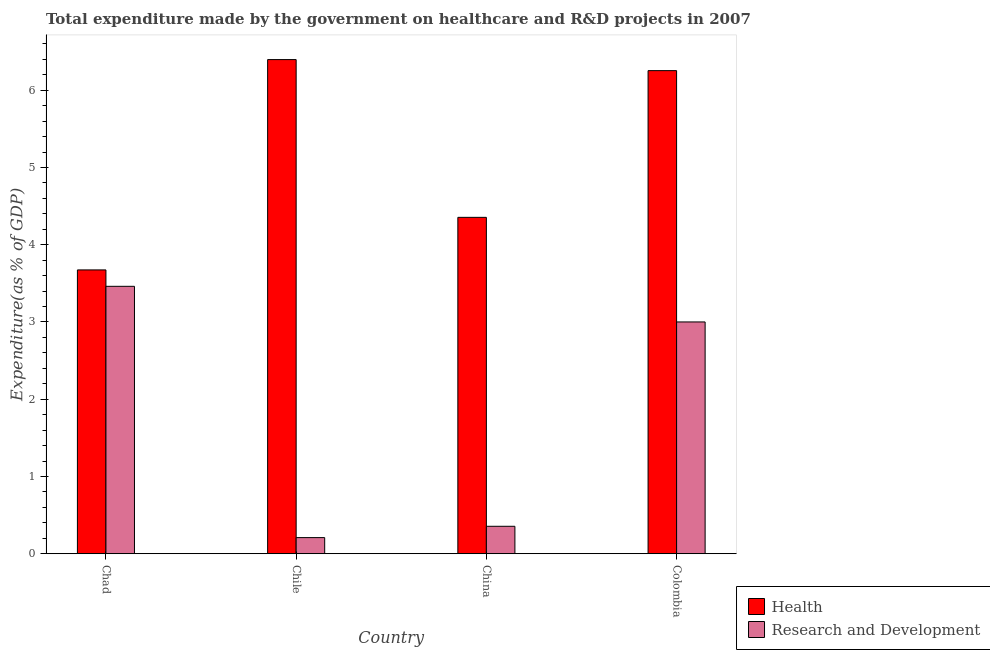How many groups of bars are there?
Ensure brevity in your answer.  4. Are the number of bars on each tick of the X-axis equal?
Make the answer very short. Yes. How many bars are there on the 1st tick from the left?
Provide a short and direct response. 2. How many bars are there on the 1st tick from the right?
Provide a short and direct response. 2. What is the label of the 1st group of bars from the left?
Your answer should be very brief. Chad. In how many cases, is the number of bars for a given country not equal to the number of legend labels?
Your answer should be compact. 0. What is the expenditure in healthcare in Chile?
Provide a short and direct response. 6.4. Across all countries, what is the maximum expenditure in healthcare?
Provide a succinct answer. 6.4. Across all countries, what is the minimum expenditure in healthcare?
Provide a succinct answer. 3.67. What is the total expenditure in r&d in the graph?
Provide a succinct answer. 7.03. What is the difference between the expenditure in r&d in Chad and that in Colombia?
Keep it short and to the point. 0.46. What is the difference between the expenditure in r&d in China and the expenditure in healthcare in Colombia?
Give a very brief answer. -5.9. What is the average expenditure in healthcare per country?
Offer a very short reply. 5.17. What is the difference between the expenditure in r&d and expenditure in healthcare in Chile?
Offer a terse response. -6.19. What is the ratio of the expenditure in healthcare in China to that in Colombia?
Your response must be concise. 0.7. What is the difference between the highest and the second highest expenditure in healthcare?
Make the answer very short. 0.14. What is the difference between the highest and the lowest expenditure in r&d?
Offer a terse response. 3.25. Is the sum of the expenditure in r&d in Chad and Chile greater than the maximum expenditure in healthcare across all countries?
Provide a succinct answer. No. What does the 1st bar from the left in Chile represents?
Make the answer very short. Health. What does the 2nd bar from the right in Chad represents?
Offer a terse response. Health. How many bars are there?
Make the answer very short. 8. How many countries are there in the graph?
Provide a short and direct response. 4. Does the graph contain any zero values?
Ensure brevity in your answer.  No. Does the graph contain grids?
Offer a terse response. No. What is the title of the graph?
Your answer should be compact. Total expenditure made by the government on healthcare and R&D projects in 2007. What is the label or title of the Y-axis?
Offer a terse response. Expenditure(as % of GDP). What is the Expenditure(as % of GDP) of Health in Chad?
Your answer should be compact. 3.67. What is the Expenditure(as % of GDP) of Research and Development in Chad?
Keep it short and to the point. 3.46. What is the Expenditure(as % of GDP) of Health in Chile?
Your answer should be very brief. 6.4. What is the Expenditure(as % of GDP) of Research and Development in Chile?
Keep it short and to the point. 0.21. What is the Expenditure(as % of GDP) of Health in China?
Your response must be concise. 4.35. What is the Expenditure(as % of GDP) in Research and Development in China?
Make the answer very short. 0.36. What is the Expenditure(as % of GDP) in Health in Colombia?
Give a very brief answer. 6.25. What is the Expenditure(as % of GDP) of Research and Development in Colombia?
Offer a terse response. 3. Across all countries, what is the maximum Expenditure(as % of GDP) in Health?
Provide a succinct answer. 6.4. Across all countries, what is the maximum Expenditure(as % of GDP) in Research and Development?
Provide a succinct answer. 3.46. Across all countries, what is the minimum Expenditure(as % of GDP) in Health?
Provide a short and direct response. 3.67. Across all countries, what is the minimum Expenditure(as % of GDP) in Research and Development?
Your answer should be compact. 0.21. What is the total Expenditure(as % of GDP) in Health in the graph?
Make the answer very short. 20.68. What is the total Expenditure(as % of GDP) of Research and Development in the graph?
Provide a succinct answer. 7.03. What is the difference between the Expenditure(as % of GDP) in Health in Chad and that in Chile?
Offer a very short reply. -2.72. What is the difference between the Expenditure(as % of GDP) of Research and Development in Chad and that in Chile?
Offer a very short reply. 3.25. What is the difference between the Expenditure(as % of GDP) of Health in Chad and that in China?
Make the answer very short. -0.68. What is the difference between the Expenditure(as % of GDP) in Research and Development in Chad and that in China?
Your answer should be very brief. 3.11. What is the difference between the Expenditure(as % of GDP) of Health in Chad and that in Colombia?
Your response must be concise. -2.58. What is the difference between the Expenditure(as % of GDP) in Research and Development in Chad and that in Colombia?
Keep it short and to the point. 0.46. What is the difference between the Expenditure(as % of GDP) of Health in Chile and that in China?
Ensure brevity in your answer.  2.04. What is the difference between the Expenditure(as % of GDP) in Research and Development in Chile and that in China?
Give a very brief answer. -0.15. What is the difference between the Expenditure(as % of GDP) in Health in Chile and that in Colombia?
Provide a succinct answer. 0.14. What is the difference between the Expenditure(as % of GDP) in Research and Development in Chile and that in Colombia?
Your response must be concise. -2.79. What is the difference between the Expenditure(as % of GDP) in Health in China and that in Colombia?
Your answer should be very brief. -1.9. What is the difference between the Expenditure(as % of GDP) in Research and Development in China and that in Colombia?
Offer a very short reply. -2.65. What is the difference between the Expenditure(as % of GDP) in Health in Chad and the Expenditure(as % of GDP) in Research and Development in Chile?
Ensure brevity in your answer.  3.47. What is the difference between the Expenditure(as % of GDP) of Health in Chad and the Expenditure(as % of GDP) of Research and Development in China?
Provide a succinct answer. 3.32. What is the difference between the Expenditure(as % of GDP) of Health in Chad and the Expenditure(as % of GDP) of Research and Development in Colombia?
Make the answer very short. 0.67. What is the difference between the Expenditure(as % of GDP) of Health in Chile and the Expenditure(as % of GDP) of Research and Development in China?
Provide a short and direct response. 6.04. What is the difference between the Expenditure(as % of GDP) of Health in Chile and the Expenditure(as % of GDP) of Research and Development in Colombia?
Provide a short and direct response. 3.4. What is the difference between the Expenditure(as % of GDP) in Health in China and the Expenditure(as % of GDP) in Research and Development in Colombia?
Provide a succinct answer. 1.35. What is the average Expenditure(as % of GDP) of Health per country?
Provide a short and direct response. 5.17. What is the average Expenditure(as % of GDP) of Research and Development per country?
Keep it short and to the point. 1.76. What is the difference between the Expenditure(as % of GDP) of Health and Expenditure(as % of GDP) of Research and Development in Chad?
Your response must be concise. 0.21. What is the difference between the Expenditure(as % of GDP) in Health and Expenditure(as % of GDP) in Research and Development in Chile?
Give a very brief answer. 6.19. What is the difference between the Expenditure(as % of GDP) in Health and Expenditure(as % of GDP) in Research and Development in China?
Keep it short and to the point. 4. What is the difference between the Expenditure(as % of GDP) in Health and Expenditure(as % of GDP) in Research and Development in Colombia?
Your answer should be compact. 3.25. What is the ratio of the Expenditure(as % of GDP) of Health in Chad to that in Chile?
Ensure brevity in your answer.  0.57. What is the ratio of the Expenditure(as % of GDP) of Research and Development in Chad to that in Chile?
Provide a short and direct response. 16.57. What is the ratio of the Expenditure(as % of GDP) in Health in Chad to that in China?
Ensure brevity in your answer.  0.84. What is the ratio of the Expenditure(as % of GDP) of Research and Development in Chad to that in China?
Your answer should be very brief. 9.74. What is the ratio of the Expenditure(as % of GDP) in Health in Chad to that in Colombia?
Your response must be concise. 0.59. What is the ratio of the Expenditure(as % of GDP) of Research and Development in Chad to that in Colombia?
Make the answer very short. 1.15. What is the ratio of the Expenditure(as % of GDP) in Health in Chile to that in China?
Ensure brevity in your answer.  1.47. What is the ratio of the Expenditure(as % of GDP) in Research and Development in Chile to that in China?
Offer a terse response. 0.59. What is the ratio of the Expenditure(as % of GDP) in Health in Chile to that in Colombia?
Provide a succinct answer. 1.02. What is the ratio of the Expenditure(as % of GDP) of Research and Development in Chile to that in Colombia?
Offer a very short reply. 0.07. What is the ratio of the Expenditure(as % of GDP) in Health in China to that in Colombia?
Your answer should be very brief. 0.7. What is the ratio of the Expenditure(as % of GDP) of Research and Development in China to that in Colombia?
Provide a succinct answer. 0.12. What is the difference between the highest and the second highest Expenditure(as % of GDP) of Health?
Your response must be concise. 0.14. What is the difference between the highest and the second highest Expenditure(as % of GDP) of Research and Development?
Keep it short and to the point. 0.46. What is the difference between the highest and the lowest Expenditure(as % of GDP) in Health?
Ensure brevity in your answer.  2.72. What is the difference between the highest and the lowest Expenditure(as % of GDP) in Research and Development?
Your answer should be compact. 3.25. 